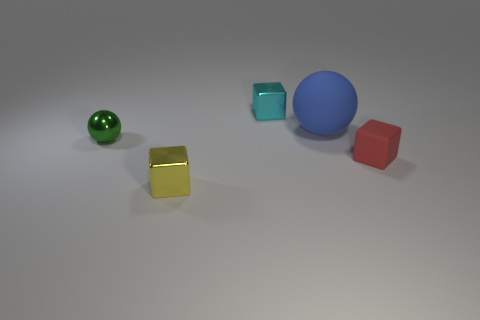Subtract all small cyan metallic cubes. How many cubes are left? 2 Add 1 purple cubes. How many objects exist? 6 Subtract all blocks. How many objects are left? 2 Subtract all cyan blocks. How many blocks are left? 2 Subtract 1 cubes. How many cubes are left? 2 Subtract all brown balls. Subtract all red cubes. How many balls are left? 2 Subtract all cyan balls. How many gray cubes are left? 0 Subtract all big purple metal things. Subtract all rubber blocks. How many objects are left? 4 Add 1 tiny green objects. How many tiny green objects are left? 2 Add 4 tiny green objects. How many tiny green objects exist? 5 